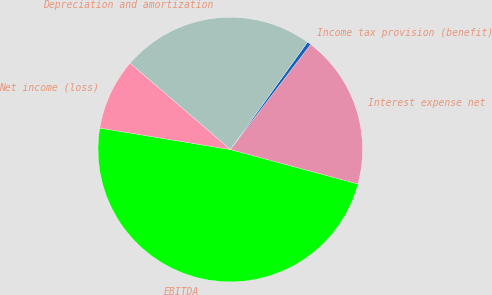<chart> <loc_0><loc_0><loc_500><loc_500><pie_chart><fcel>EBITDA<fcel>Interest expense net<fcel>Income tax provision (benefit)<fcel>Depreciation and amortization<fcel>Net income (loss)<nl><fcel>48.4%<fcel>18.81%<fcel>0.47%<fcel>23.6%<fcel>8.72%<nl></chart> 